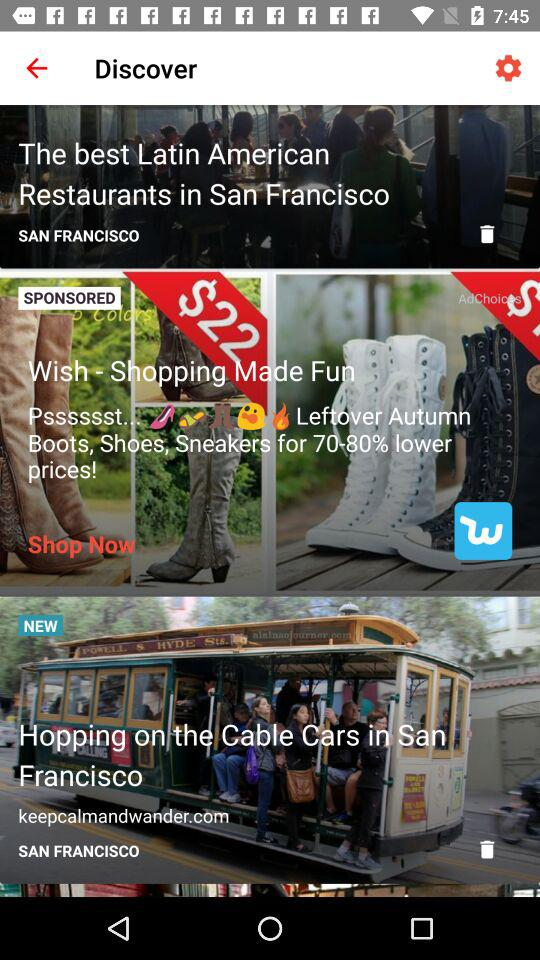What's the website address mentioned in the "Hopping on the Cable Cars in San Francisco" article? The website address mentioned is "keepcalmandwander.com". 